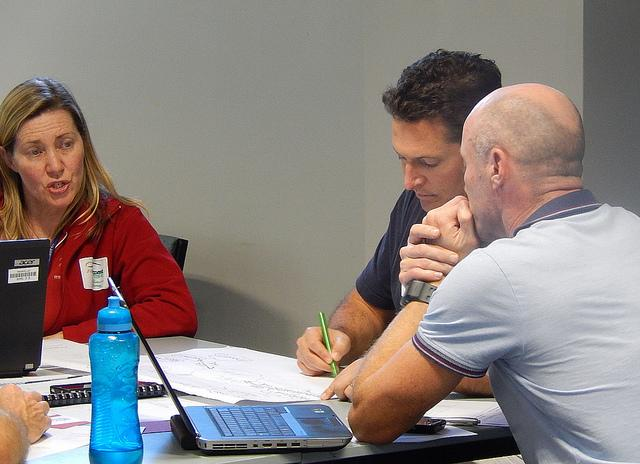The blue bottle is there to satisfy what need? Please explain your reasoning. thirst. The bottle is for thirst. 